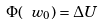<formula> <loc_0><loc_0><loc_500><loc_500>\Phi ( \ w _ { 0 } ) = \Delta U</formula> 